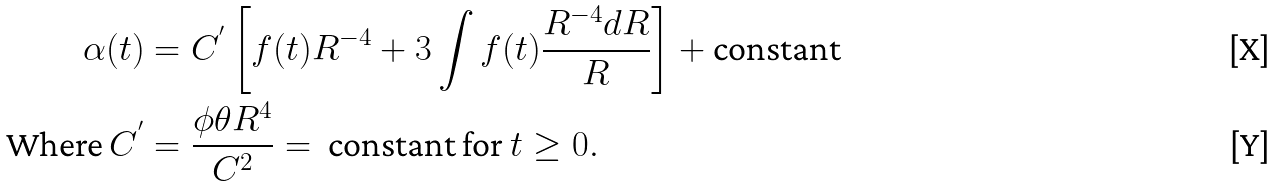<formula> <loc_0><loc_0><loc_500><loc_500>\alpha ( t ) & = C ^ { ^ { \prime } } \left [ f ( t ) R ^ { - 4 } + 3 \int f ( t ) \frac { R ^ { - 4 } d R } { R } \right ] + \text {constant} \\ \text {Where } C ^ { ^ { \prime } } & = \frac { \phi \theta R ^ { 4 } } { C ^ { 2 } } = \text { constant  for } t \geq 0 .</formula> 